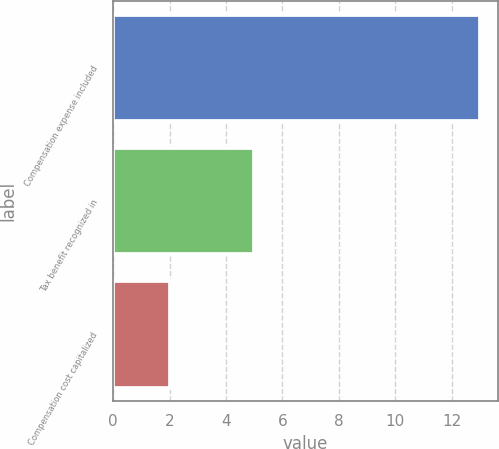Convert chart. <chart><loc_0><loc_0><loc_500><loc_500><bar_chart><fcel>Compensation expense included<fcel>Tax benefit recognized in<fcel>Compensation cost capitalized<nl><fcel>13<fcel>5<fcel>2<nl></chart> 